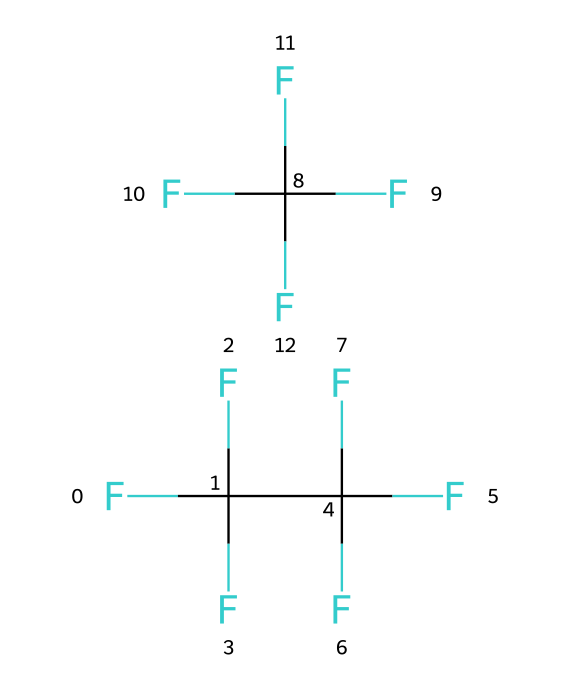What is the name of the refrigerant represented by the SMILES? The SMILES representation corresponds to R-410A, which is a blend of two refrigerants and is commonly used in modern HVAC systems.
Answer: R-410A How many fluorine atoms are in R-410A? Analyzing the SMILES structure, there are a total of 8 fluorine (F) atoms present: 5 from the first component and 3 from the second component.
Answer: 8 What type of chemical compound is R-410A? The SMILES represents a hydrofluorocarbon (HFC), which is characterized by hydrogen, fluorine, and carbon in its structure.
Answer: hydrofluorocarbon What is the total number of carbon atoms in R-410A? Observing the SMILES, there are 2 carbon (C) atoms in each component of the blend, resulting in a total of 2 carbon atoms for R-410A.
Answer: 2 Why does R-410A have a low ozone depletion potential? The low ozone depletion potential is due to the absence of chlorine and bromine atoms in its structure, which are primarily responsible for ozone layer depletion.
Answer: absence of chlorine What phase of matter is R-410A typically under when used in HVAC systems? In HVAC applications, R-410A is typically used as a refrigerant in a gaseous phase, transitioning between liquid and gas during the refrigeration cycle.
Answer: gaseous What role do fluorine atoms play in R-410A's properties? Fluorine atoms contribute to R-410A's stability and low toxicity, enhancing its efficiency as a refrigerant by lowering flammability and improving thermodynamic performance.
Answer: stability and low toxicity 